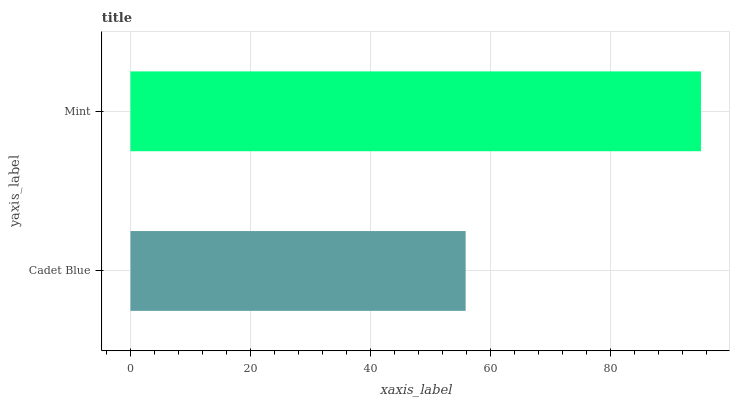Is Cadet Blue the minimum?
Answer yes or no. Yes. Is Mint the maximum?
Answer yes or no. Yes. Is Mint the minimum?
Answer yes or no. No. Is Mint greater than Cadet Blue?
Answer yes or no. Yes. Is Cadet Blue less than Mint?
Answer yes or no. Yes. Is Cadet Blue greater than Mint?
Answer yes or no. No. Is Mint less than Cadet Blue?
Answer yes or no. No. Is Mint the high median?
Answer yes or no. Yes. Is Cadet Blue the low median?
Answer yes or no. Yes. Is Cadet Blue the high median?
Answer yes or no. No. Is Mint the low median?
Answer yes or no. No. 